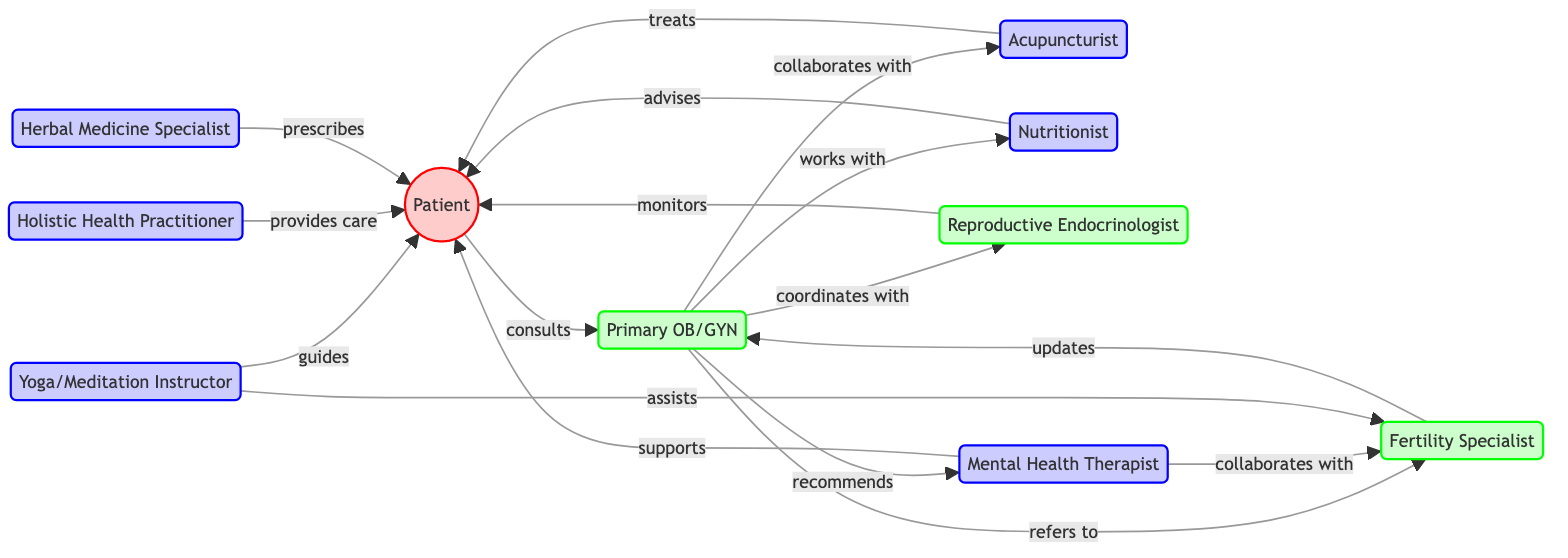What is the total number of nodes in the diagram? The nodes listed in the diagram include the Patient, Primary Obstetrician/Gynecologist, Fertility Specialist, Acupuncturist, Nutritionist, Reproductive Endocrinologist, Mental Health Therapist, Yoga and Meditation Instructor, Holistic Health Practitioner, and Herbal Medicine Specialist. Counting these, there are a total of 10 nodes.
Answer: 10 Who does the Primary Obstetrician/Gynecologist refer to? According to the diagram, the Primary Obstetrician/Gynecologist refers to the Fertility Specialist, as indicated by the edge labeled "refers to" from node 2 to node 3.
Answer: Fertility Specialist How many therapists are connected to the Patient? The Patient is connected to four therapists: Acupuncturist, Nutritionist, Mental Health Therapist, and Yoga and Meditation Instructor. These connections are shown through the edges labeled "treats," "advises," "supports," and "guides." Thus, we count a total of 4 therapists.
Answer: 4 Which node is recommended by the Primary Obstetrician/Gynecologist? The Primary Obstetrician/Gynecologist recommends the Mental Health Therapist, as indicated by the edge labeled "recommends" connecting node 2 (OB/GYN) to node 7 (Mental Health Therapist).
Answer: Mental Health Therapist What is the relationship between the Fertility Specialist and the Primary Obstetrician/Gynecologist? The relationship is that the Fertility Specialist updates the Primary Obstetrician/Gynecologist. This is represented by the edge labeled "updates" from node 3 to node 2 in the diagram.
Answer: updates 